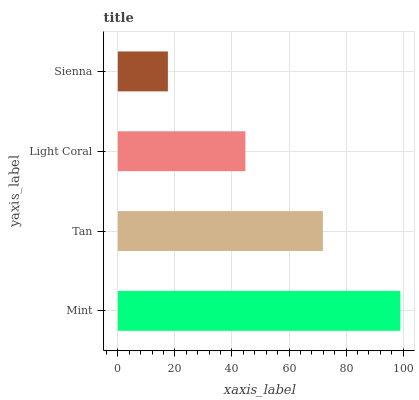Is Sienna the minimum?
Answer yes or no. Yes. Is Mint the maximum?
Answer yes or no. Yes. Is Tan the minimum?
Answer yes or no. No. Is Tan the maximum?
Answer yes or no. No. Is Mint greater than Tan?
Answer yes or no. Yes. Is Tan less than Mint?
Answer yes or no. Yes. Is Tan greater than Mint?
Answer yes or no. No. Is Mint less than Tan?
Answer yes or no. No. Is Tan the high median?
Answer yes or no. Yes. Is Light Coral the low median?
Answer yes or no. Yes. Is Sienna the high median?
Answer yes or no. No. Is Sienna the low median?
Answer yes or no. No. 